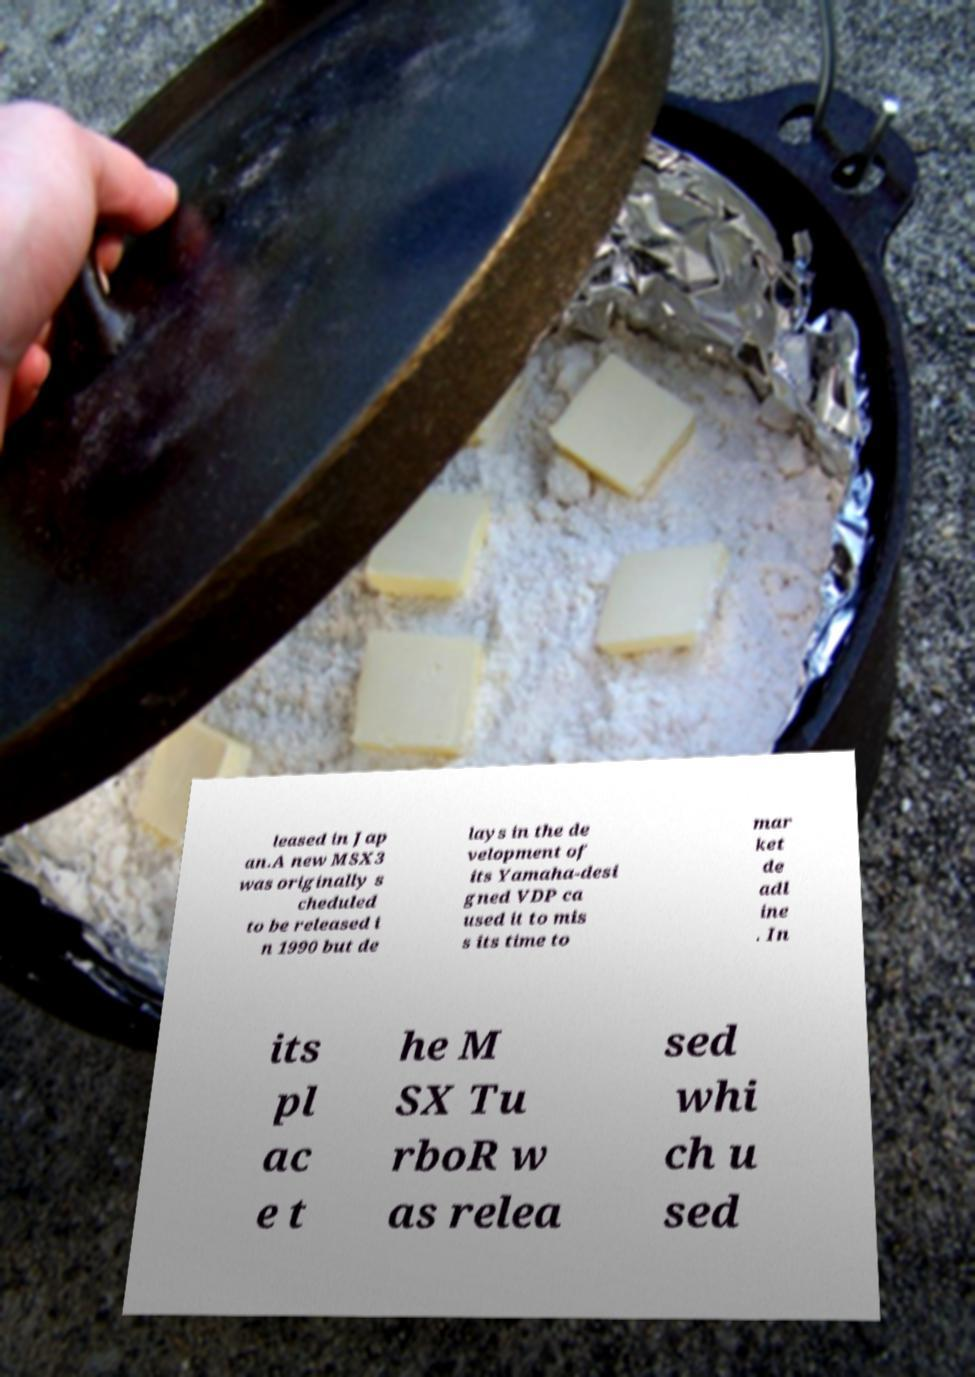There's text embedded in this image that I need extracted. Can you transcribe it verbatim? leased in Jap an.A new MSX3 was originally s cheduled to be released i n 1990 but de lays in the de velopment of its Yamaha-desi gned VDP ca used it to mis s its time to mar ket de adl ine . In its pl ac e t he M SX Tu rboR w as relea sed whi ch u sed 